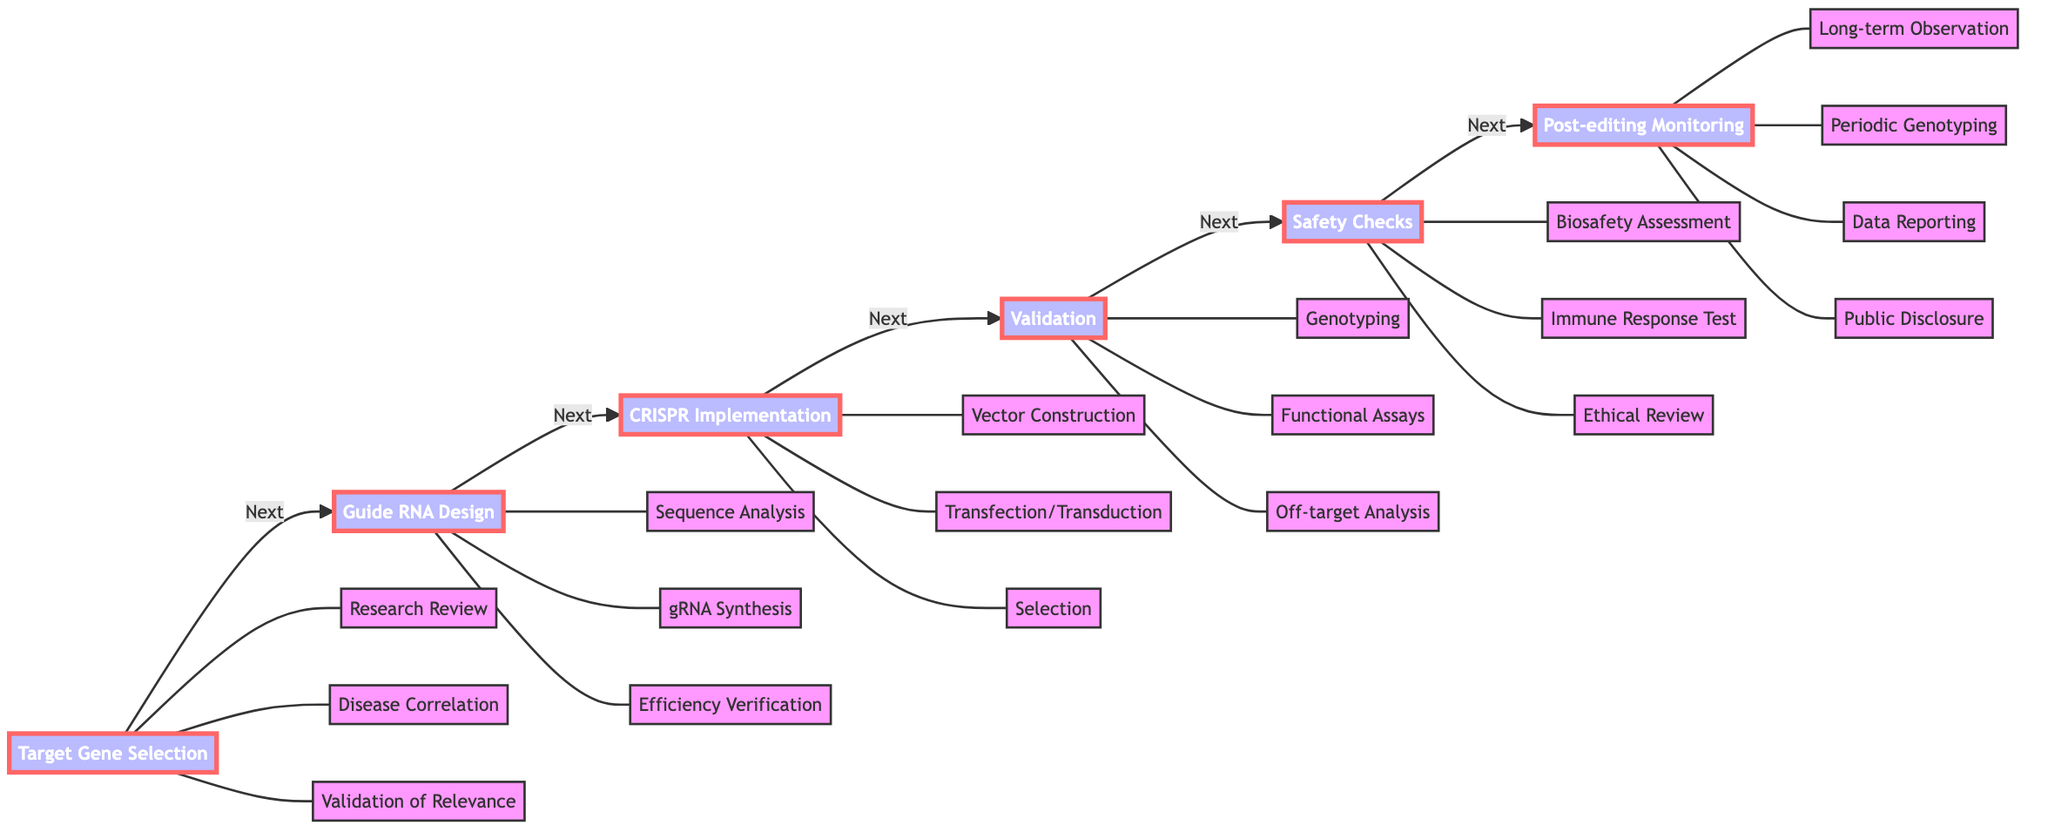What is the first step in the gene editing workflow? The first step in the gene editing workflow is identified in the diagram as "Target Gene Selection," which is labeled as the leftmost node.
Answer: Target Gene Selection How many tasks are associated with "Validation"? By counting the tasks directly connected to the "Validation" step in the diagram, there are three tasks: Genotyping, Functional Assays, and Off-target Analysis.
Answer: 3 Which step follows "CRISPR Implementation"? Following the directed flow from the "CRISPR Implementation" step, the next step indicated in the diagram is "Validation."
Answer: Validation What is the purpose of "Safety Checks"? The "Safety Checks" step is described in the diagram as ensuring that gene editing does not cause unintended consequences, which suggests a comprehensive evaluation.
Answer: Ensure unintended consequences In which step is "gRNA Synthesis" performed? The task "gRNA Synthesis" is directly connected to the "Guide RNA Design" step, making it clear that this task is performed within that step.
Answer: Guide RNA Design How many total steps are there in the gene editing workflow? By examining the main steps listed in the diagram, there are six major steps from "Target Gene Selection" through "Post-editing Monitoring."
Answer: 6 Which tasks are included under "Post-editing Monitoring"? The tasks included under "Post-editing Monitoring" in the diagram are: Long-term Observation, Periodic Genotyping, Data Reporting, and Public Disclosure, which are all connected to that step.
Answer: Long-term Observation, Periodic Genotyping, Data Reporting, Public Disclosure What relationship does "Guide RNA Design" have with "CRISPR Implementation"? The relationship between "Guide RNA Design" and "CRISPR Implementation" is sequential, as "Guide RNA Design" is the step that directly leads to "CRISPR Implementation" in the workflow.
Answer: Sequential relationship What kind of analysis is performed during the "Off-target Analysis"? The "Off-target Analysis" task specifically involves examining potential off-target effects, indicating that it focuses on assessing unintended modifications in the genome.
Answer: Examine potential off-target effects 